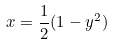<formula> <loc_0><loc_0><loc_500><loc_500>x = \frac { 1 } { 2 } ( 1 - y ^ { 2 } )</formula> 